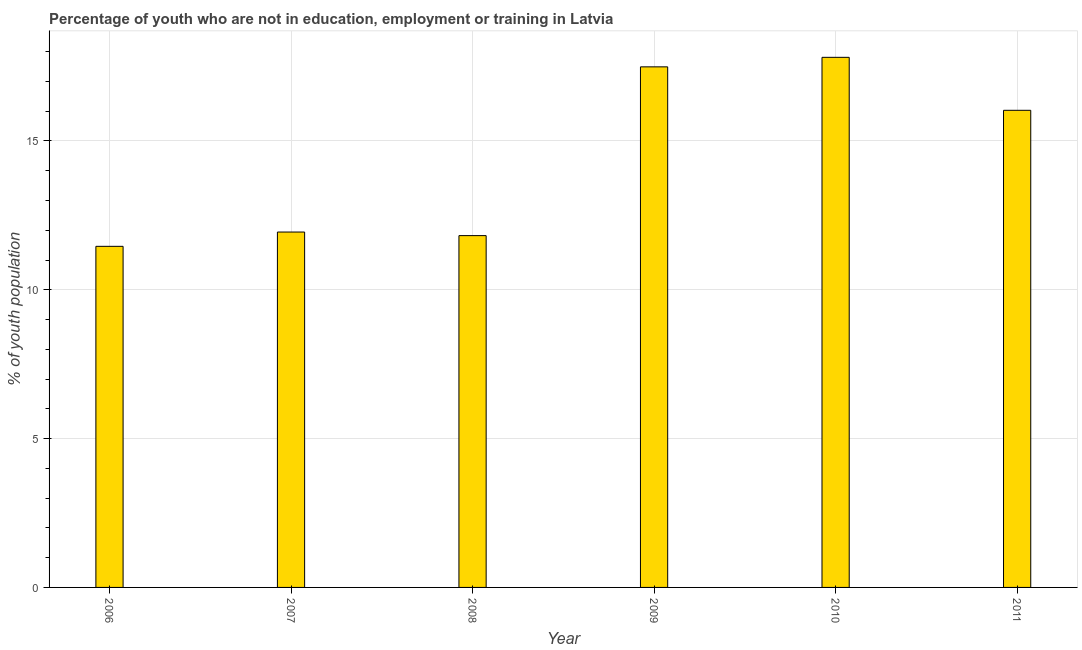What is the title of the graph?
Your answer should be compact. Percentage of youth who are not in education, employment or training in Latvia. What is the label or title of the Y-axis?
Provide a succinct answer. % of youth population. What is the unemployed youth population in 2010?
Offer a terse response. 17.81. Across all years, what is the maximum unemployed youth population?
Ensure brevity in your answer.  17.81. Across all years, what is the minimum unemployed youth population?
Offer a terse response. 11.46. In which year was the unemployed youth population minimum?
Your answer should be compact. 2006. What is the sum of the unemployed youth population?
Provide a succinct answer. 86.55. What is the difference between the unemployed youth population in 2008 and 2010?
Your answer should be compact. -5.99. What is the average unemployed youth population per year?
Your response must be concise. 14.43. What is the median unemployed youth population?
Offer a terse response. 13.99. In how many years, is the unemployed youth population greater than 6 %?
Provide a succinct answer. 6. What is the ratio of the unemployed youth population in 2008 to that in 2009?
Make the answer very short. 0.68. Is the difference between the unemployed youth population in 2009 and 2011 greater than the difference between any two years?
Offer a very short reply. No. What is the difference between the highest and the second highest unemployed youth population?
Keep it short and to the point. 0.32. Is the sum of the unemployed youth population in 2006 and 2010 greater than the maximum unemployed youth population across all years?
Your answer should be very brief. Yes. What is the difference between the highest and the lowest unemployed youth population?
Your response must be concise. 6.35. In how many years, is the unemployed youth population greater than the average unemployed youth population taken over all years?
Provide a succinct answer. 3. Are all the bars in the graph horizontal?
Provide a short and direct response. No. How many years are there in the graph?
Provide a succinct answer. 6. What is the % of youth population of 2006?
Your answer should be compact. 11.46. What is the % of youth population of 2007?
Ensure brevity in your answer.  11.94. What is the % of youth population of 2008?
Keep it short and to the point. 11.82. What is the % of youth population in 2009?
Your answer should be compact. 17.49. What is the % of youth population in 2010?
Your answer should be compact. 17.81. What is the % of youth population of 2011?
Your answer should be compact. 16.03. What is the difference between the % of youth population in 2006 and 2007?
Offer a terse response. -0.48. What is the difference between the % of youth population in 2006 and 2008?
Your response must be concise. -0.36. What is the difference between the % of youth population in 2006 and 2009?
Give a very brief answer. -6.03. What is the difference between the % of youth population in 2006 and 2010?
Your response must be concise. -6.35. What is the difference between the % of youth population in 2006 and 2011?
Keep it short and to the point. -4.57. What is the difference between the % of youth population in 2007 and 2008?
Ensure brevity in your answer.  0.12. What is the difference between the % of youth population in 2007 and 2009?
Provide a succinct answer. -5.55. What is the difference between the % of youth population in 2007 and 2010?
Keep it short and to the point. -5.87. What is the difference between the % of youth population in 2007 and 2011?
Your answer should be compact. -4.09. What is the difference between the % of youth population in 2008 and 2009?
Provide a short and direct response. -5.67. What is the difference between the % of youth population in 2008 and 2010?
Make the answer very short. -5.99. What is the difference between the % of youth population in 2008 and 2011?
Your answer should be compact. -4.21. What is the difference between the % of youth population in 2009 and 2010?
Your answer should be very brief. -0.32. What is the difference between the % of youth population in 2009 and 2011?
Your answer should be very brief. 1.46. What is the difference between the % of youth population in 2010 and 2011?
Offer a terse response. 1.78. What is the ratio of the % of youth population in 2006 to that in 2007?
Offer a terse response. 0.96. What is the ratio of the % of youth population in 2006 to that in 2009?
Give a very brief answer. 0.66. What is the ratio of the % of youth population in 2006 to that in 2010?
Give a very brief answer. 0.64. What is the ratio of the % of youth population in 2006 to that in 2011?
Give a very brief answer. 0.71. What is the ratio of the % of youth population in 2007 to that in 2008?
Give a very brief answer. 1.01. What is the ratio of the % of youth population in 2007 to that in 2009?
Provide a succinct answer. 0.68. What is the ratio of the % of youth population in 2007 to that in 2010?
Ensure brevity in your answer.  0.67. What is the ratio of the % of youth population in 2007 to that in 2011?
Give a very brief answer. 0.74. What is the ratio of the % of youth population in 2008 to that in 2009?
Ensure brevity in your answer.  0.68. What is the ratio of the % of youth population in 2008 to that in 2010?
Provide a succinct answer. 0.66. What is the ratio of the % of youth population in 2008 to that in 2011?
Ensure brevity in your answer.  0.74. What is the ratio of the % of youth population in 2009 to that in 2011?
Your answer should be compact. 1.09. What is the ratio of the % of youth population in 2010 to that in 2011?
Offer a very short reply. 1.11. 